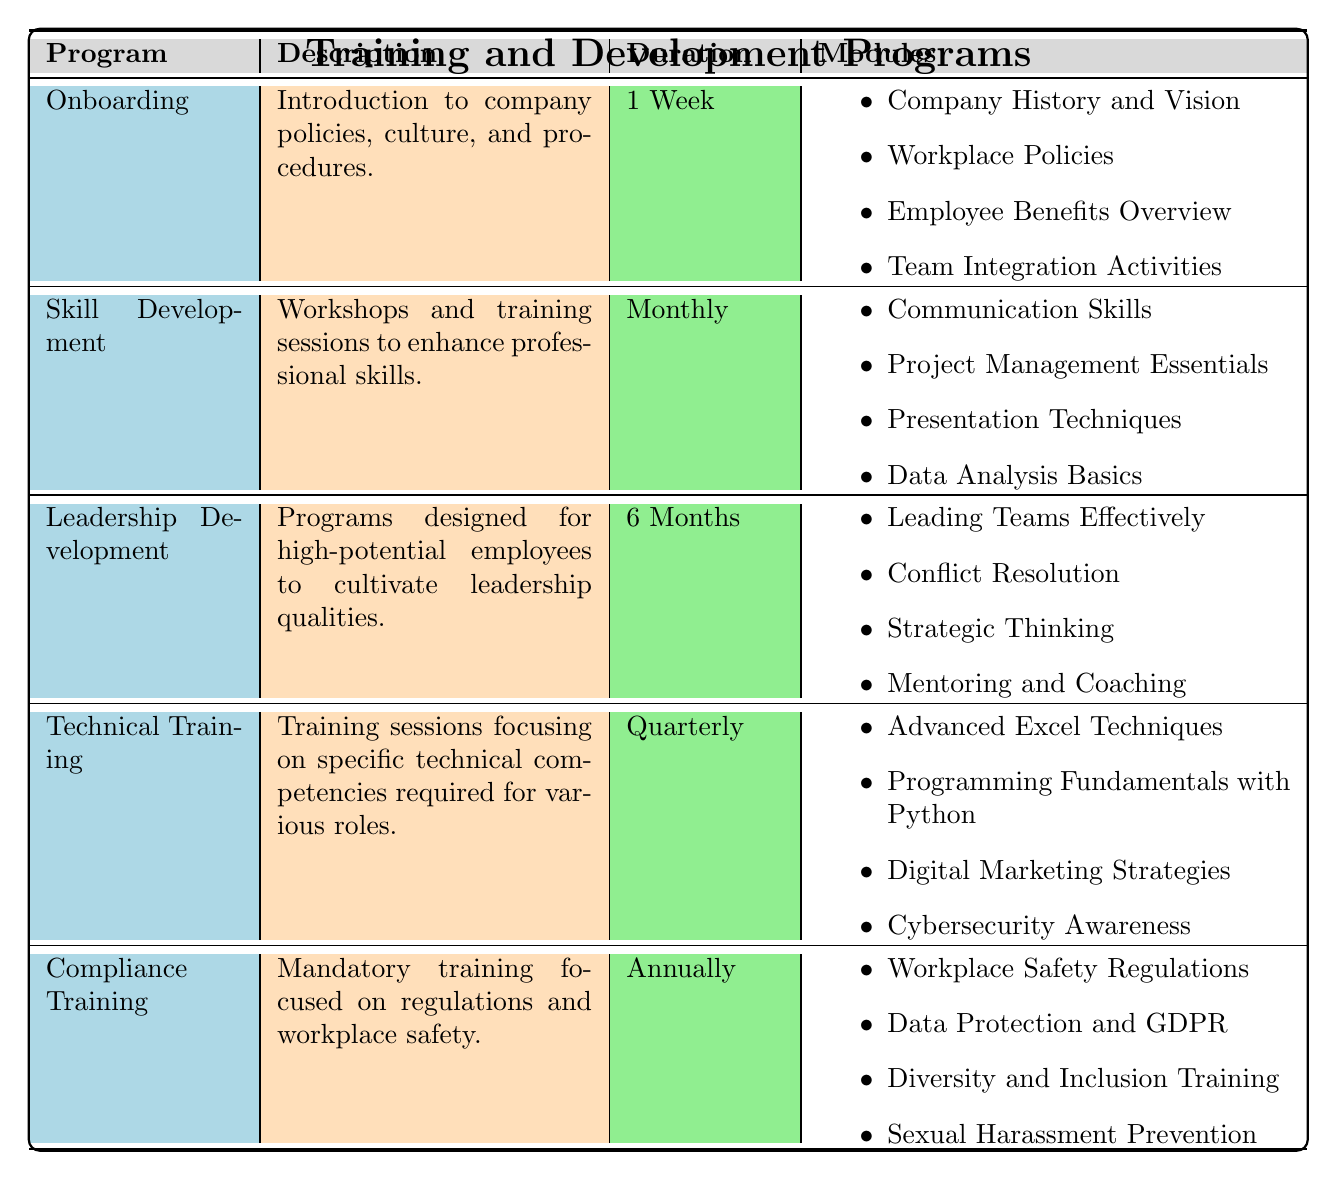What is the duration of the Onboarding program? The duration of the Onboarding program is specified in the table under the 'Duration' column for Onboarding. It clearly states "1 Week".
Answer: 1 Week How many modules are included in the Leadership Development program? The Leadership Development program has a list of modules provided under the 'Modules' column. There are four modules listed: "Leading Teams Effectively," "Conflict Resolution," "Strategic Thinking," and "Mentoring and Coaching."
Answer: 4 modules Is Technical Training offered more than once a year? The duration for Technical Training is shown as "Quarterly," which means it is offered four times a year. Thus, the statement that it is offered more than once a year is true.
Answer: Yes Which training program focuses on enhancing professional skills? The table indicates that the 'Skill Development' program is designed specifically for enhancing professional skills, as reflected in its description.
Answer: Skill Development What is the average duration of all training programs listed? To find the average duration, convert each to a numerical value: Onboarding (1 week), Skill Development (1 month), Leadership Development (6 months), Technical Training (3 months), Compliance Training (12 months). In weeks: 1 + 4 + 24 + 12 + 52 = 93 weeks for 5 programs. Average duration is 93 / 5 = 18.6 weeks, which can be approximately expressed as 19 weeks.
Answer: 19 weeks Is there a module specifically about Cybersecurity in the Technical Training program? The modules under Technical Training include "Cybersecurity Awareness." Therefore, the statement that a module focuses on Cybersecurity is true.
Answer: Yes What are the two modules included in Compliance Training? The modules for Compliance Training are listed. Two of them from the list are "Data Protection and GDPR" and "Diversity and Inclusion Training."
Answer: Data Protection and GDPR, Diversity and Inclusion Training Which program has a longer duration, Leadership Development or Compliance Training? The Leadership Development program lasts for "6 Months," while Compliance Training lasts "Annually," which is equivalent to 12 months. Since 12 months is greater than 6 months, Compliance Training has a longer duration.
Answer: Compliance Training 